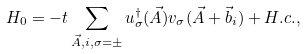<formula> <loc_0><loc_0><loc_500><loc_500>H _ { 0 } = - t \sum _ { \vec { A } , i , \sigma = \pm } u ^ { \dagger } _ { \sigma } ( \vec { A } ) v _ { \sigma } ( \vec { A } + \vec { b } _ { i } ) + H . c . ,</formula> 